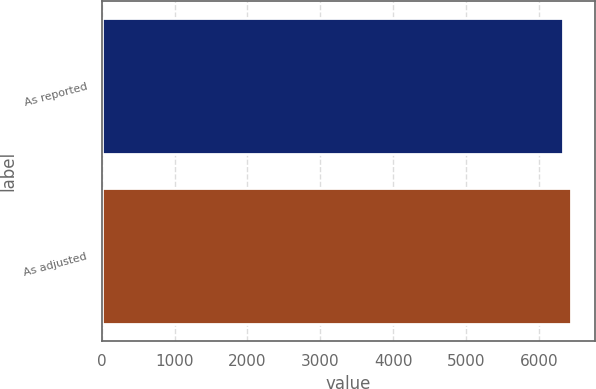Convert chart to OTSL. <chart><loc_0><loc_0><loc_500><loc_500><bar_chart><fcel>As reported<fcel>As adjusted<nl><fcel>6328<fcel>6438<nl></chart> 